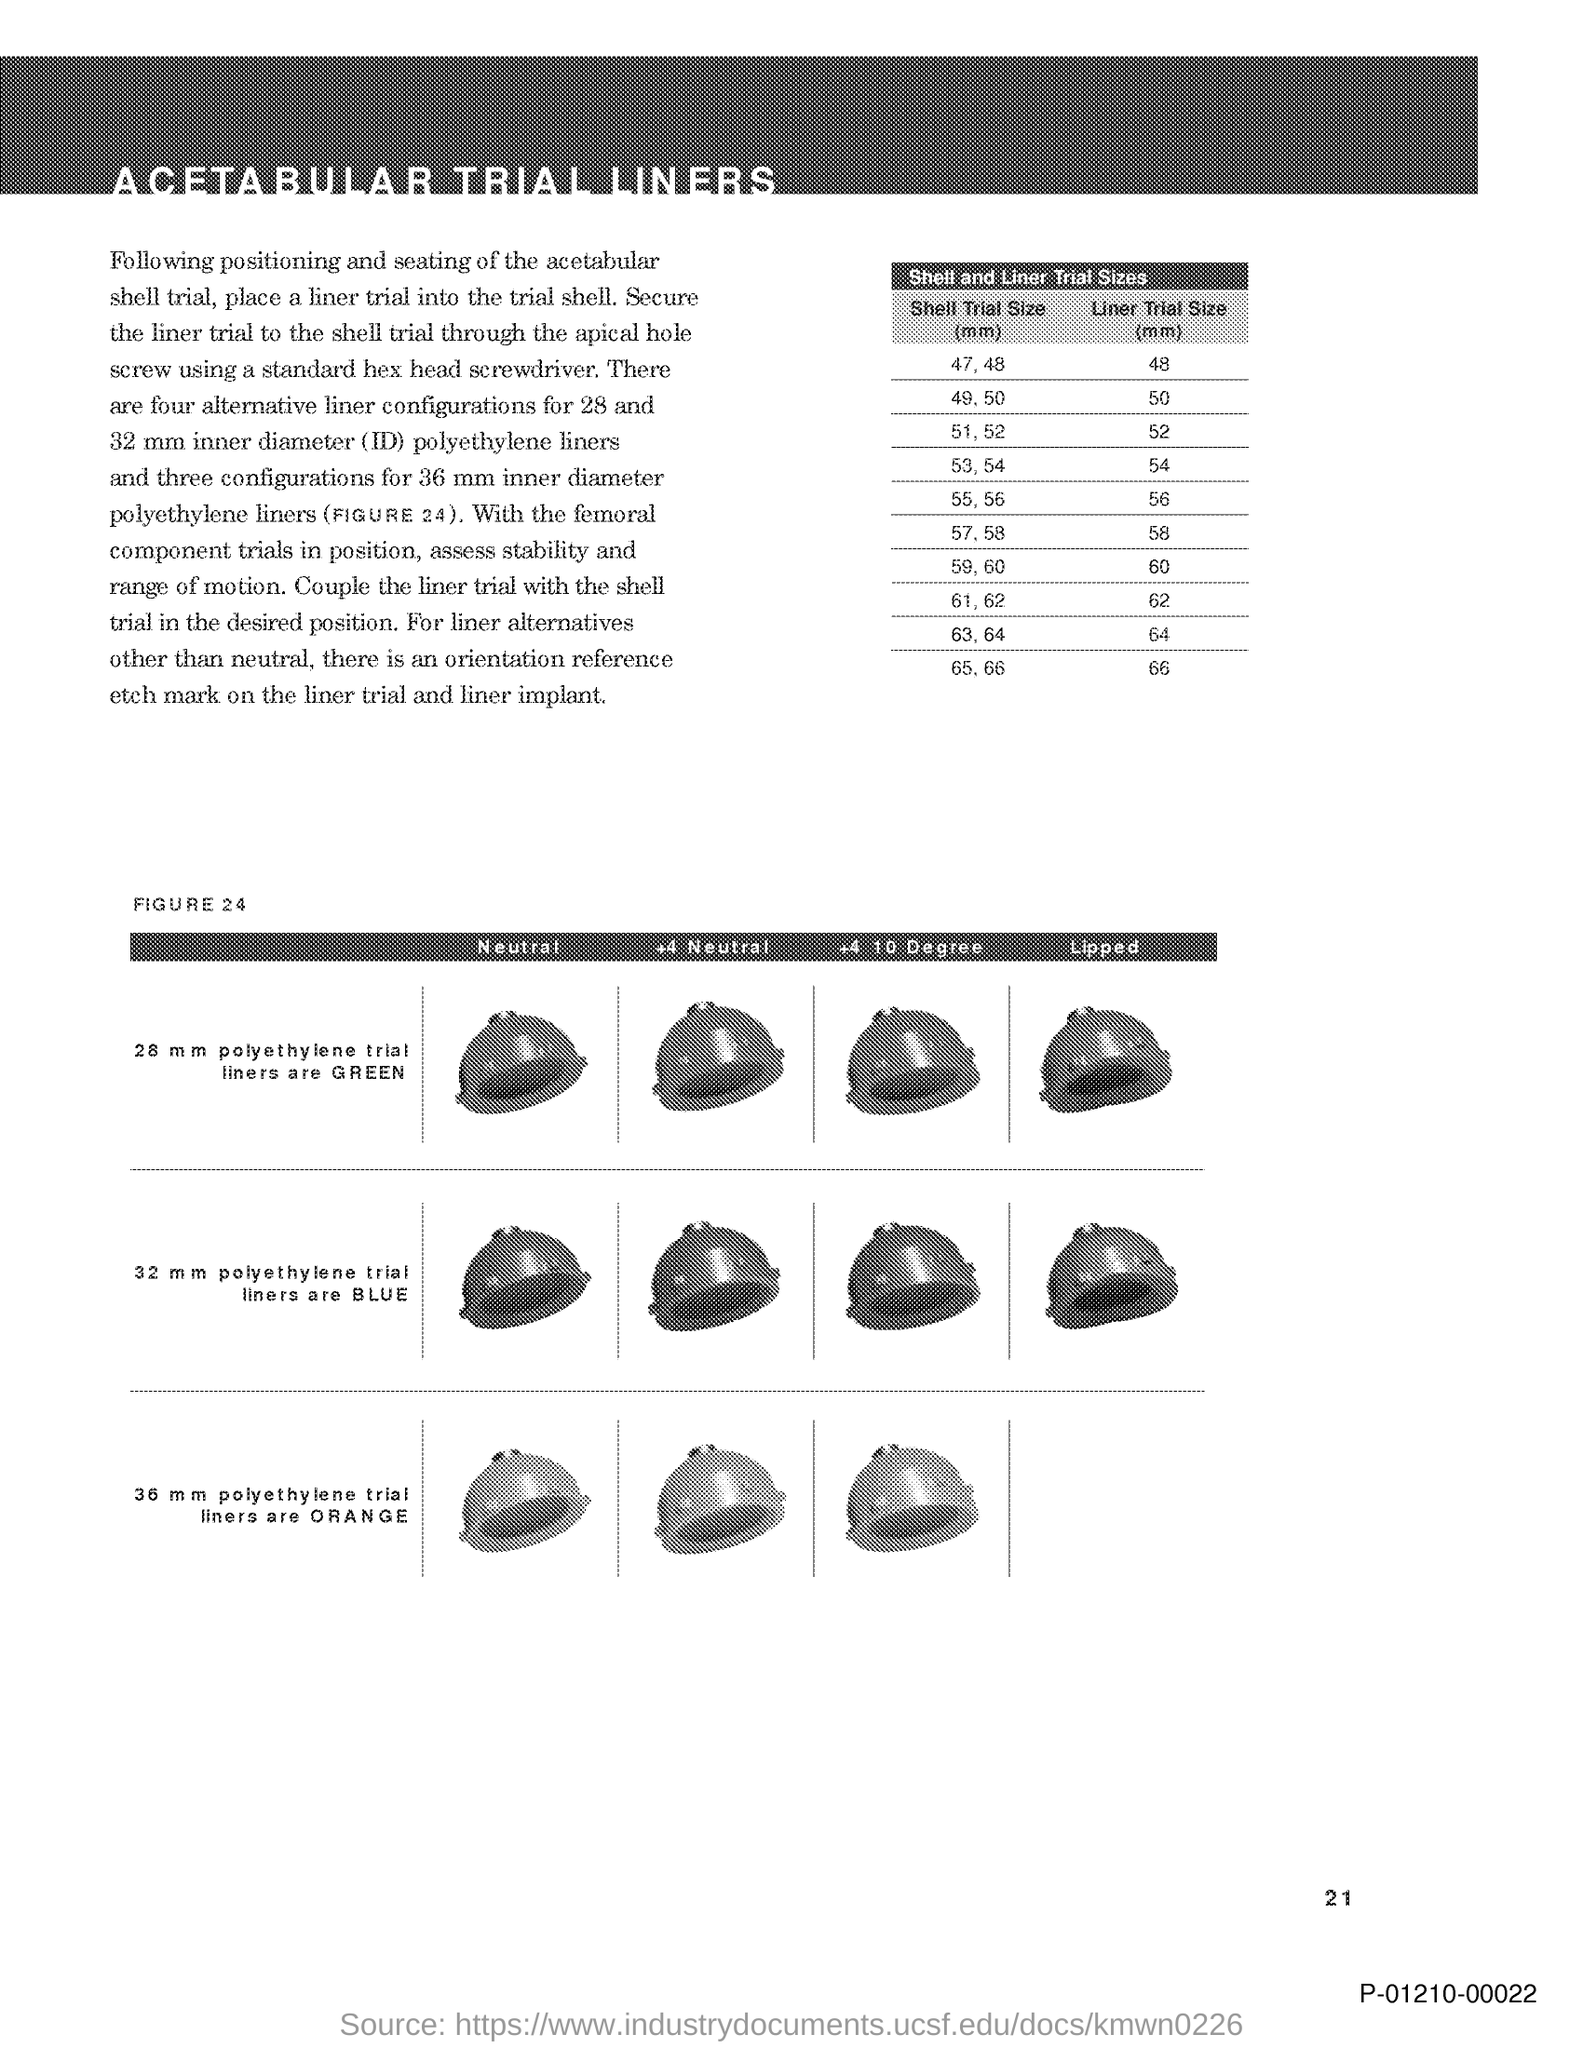Identify some key points in this picture. The liner trial size corresponding to a shell trial size of 47.48 mm is 48 mm. The document title is "ACETABULAR TRIAL LINERS... The title of the table is 'Shell and Liner Trial Sizes.' 